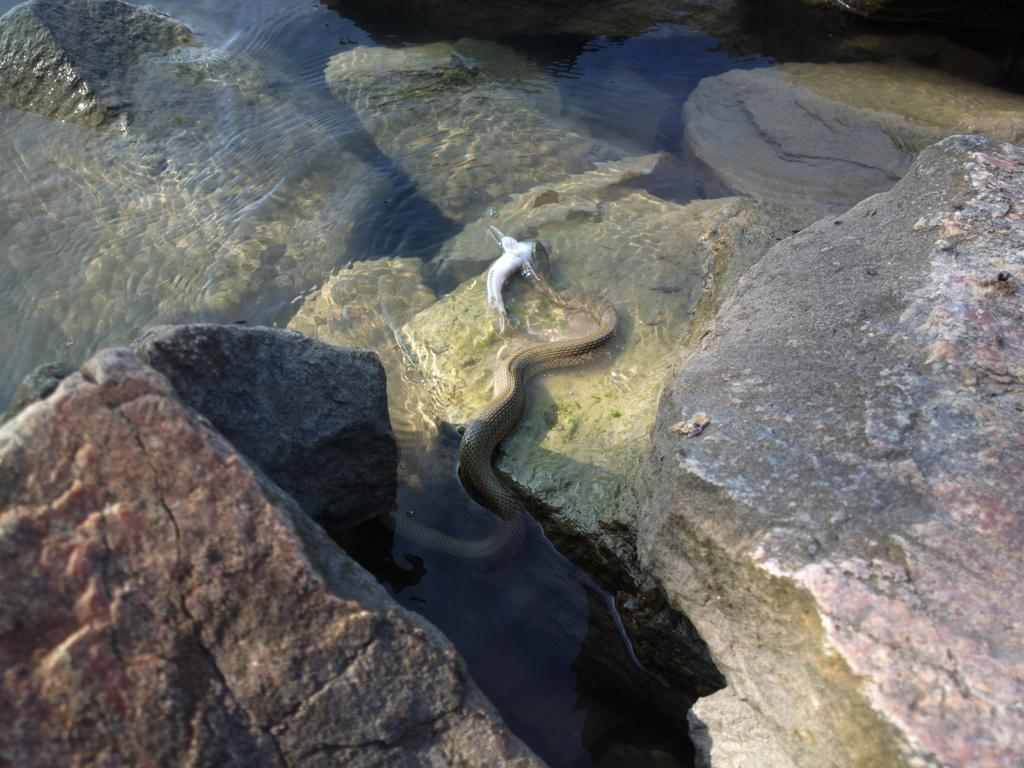What animal is the main subject of the image? There is a snake in the image. What is the snake holding in the image? The snake is holding a fish in the image. Where are the snake and fish located? The snake and fish are in the water in the image. What can be seen on the sides of the image? There are rocks on both the right and left sides of the image. What type of drawer is visible in the image? There is no drawer present in the image. Who is the representative of the snake in the image? There is no representative of the snake in the image; it is the actual snake itself. 